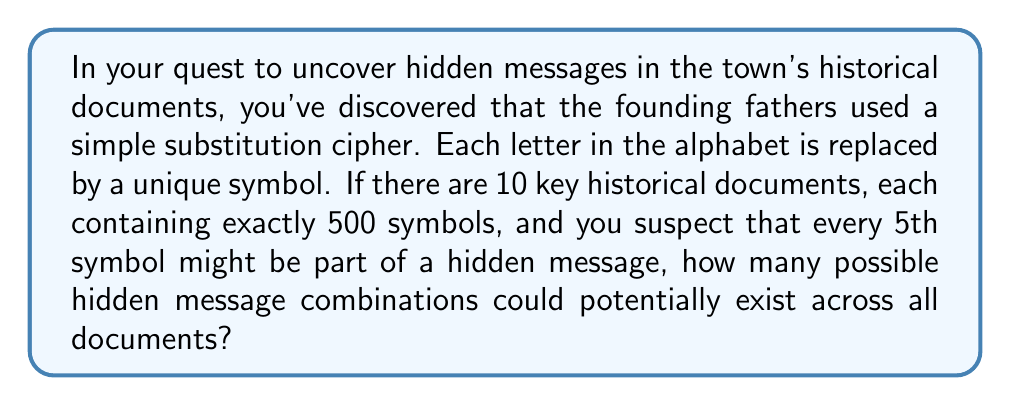Help me with this question. Let's break this problem down step-by-step:

1) First, we need to determine how many symbols in each document could be part of the hidden message:
   $\frac{500}{5} = 100$ symbols per document

2) Since there are 10 documents, the total number of symbols that could be part of hidden messages is:
   $100 \times 10 = 1000$ symbols

3) Each symbol could represent any of the 26 letters in the English alphabet. This is where we apply combinatorics.

4) For each position in the hidden message, we have 26 choices. This is repeated for all 1000 positions.

5) This scenario is a perfect application for the multiplication principle in combinatorics. When we have a series of independent choices, we multiply the number of possibilities for each choice.

6) Therefore, the total number of possible hidden message combinations is:

   $$ 26^{1000} $$

7) This is an incredibly large number. To give some perspective:

   $$ 26^{1000} \approx 3.142 \times 10^{1491} $$

This astronomical number underscores the complexity and intrigue of potential hidden messages, fueling the sensationalist narrative about the town's secret history.
Answer: $26^{1000}$ 